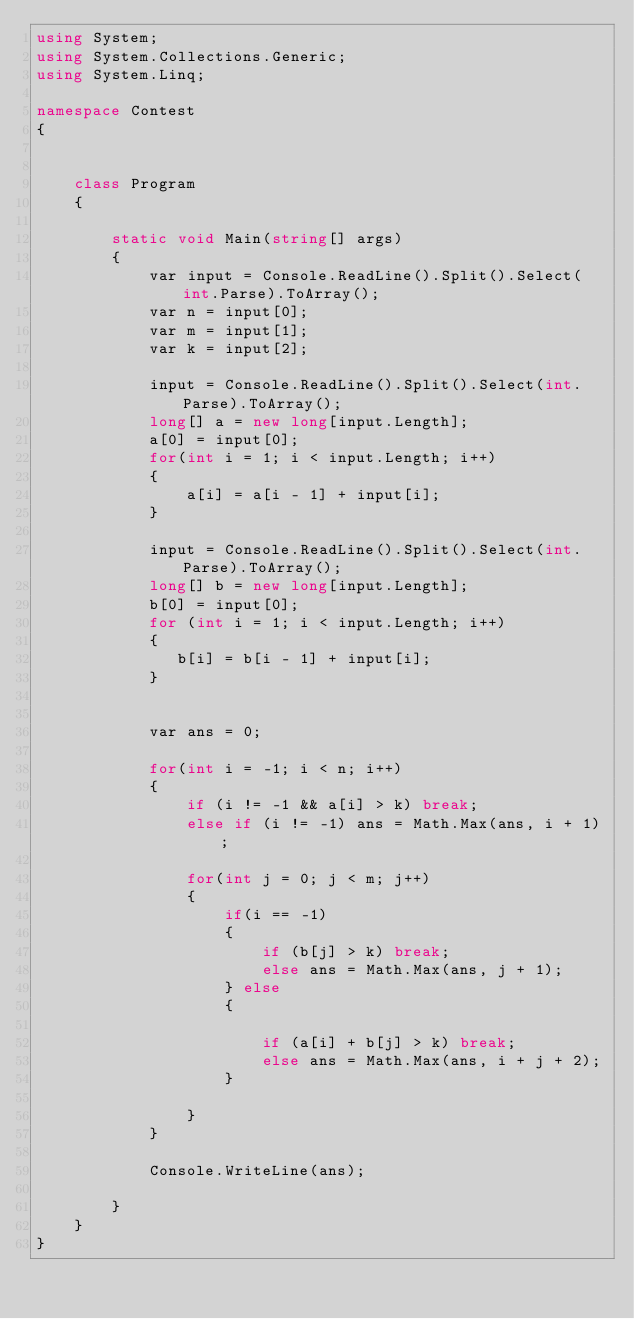Convert code to text. <code><loc_0><loc_0><loc_500><loc_500><_C#_>using System;
using System.Collections.Generic;
using System.Linq;

namespace Contest
{


    class Program
    {

        static void Main(string[] args)
        {
            var input = Console.ReadLine().Split().Select(int.Parse).ToArray();
            var n = input[0];
            var m = input[1];
            var k = input[2];

            input = Console.ReadLine().Split().Select(int.Parse).ToArray();
            long[] a = new long[input.Length];
            a[0] = input[0];
            for(int i = 1; i < input.Length; i++)
            {
                a[i] = a[i - 1] + input[i];
            }

            input = Console.ReadLine().Split().Select(int.Parse).ToArray();
            long[] b = new long[input.Length];
            b[0] = input[0];
            for (int i = 1; i < input.Length; i++)
            {
               b[i] = b[i - 1] + input[i];
            }


            var ans = 0;

            for(int i = -1; i < n; i++)
            {
                if (i != -1 && a[i] > k) break;
                else if (i != -1) ans = Math.Max(ans, i + 1);

                for(int j = 0; j < m; j++)
                {
                    if(i == -1)
                    {
                        if (b[j] > k) break;
                        else ans = Math.Max(ans, j + 1);
                    } else
                    {

                        if (a[i] + b[j] > k) break;
                        else ans = Math.Max(ans, i + j + 2);
                    }

                }
            }

            Console.WriteLine(ans);
            
        }
    }
}</code> 